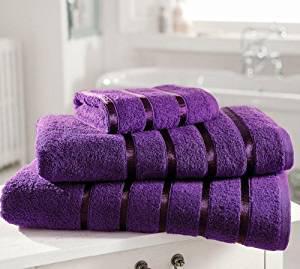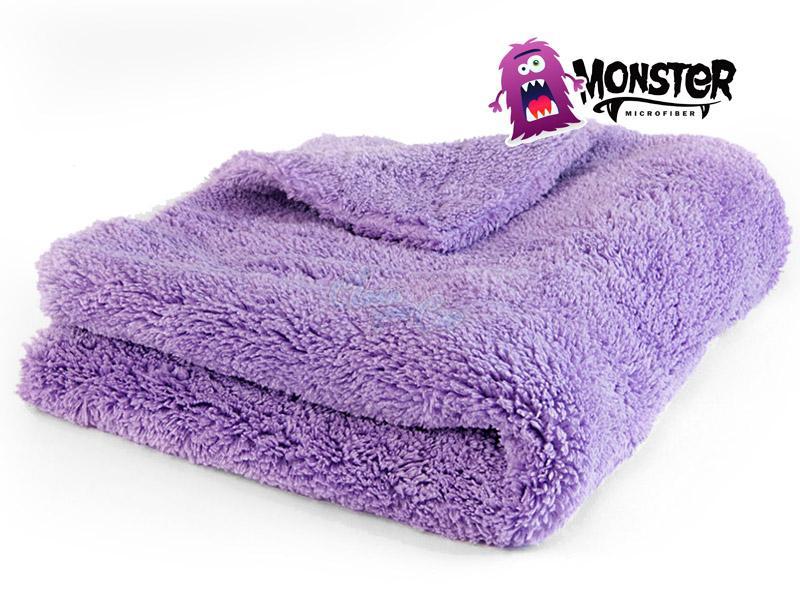The first image is the image on the left, the second image is the image on the right. Given the left and right images, does the statement "There are exactly three towels in the right image." hold true? Answer yes or no. No. 